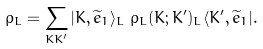<formula> <loc_0><loc_0><loc_500><loc_500>\rho _ { L } = \sum _ { K K ^ { \prime } } | K , \widetilde { e } _ { 1 } \rangle _ { L \text { } } \rho _ { L } ( K ; K ^ { \prime } ) _ { L } \langle K ^ { \prime } , \widetilde { e } _ { 1 } | .</formula> 